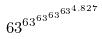<formula> <loc_0><loc_0><loc_500><loc_500>6 3 ^ { 6 3 ^ { 6 3 ^ { 6 3 ^ { 6 3 ^ { 4 . 8 2 7 } } } } }</formula> 